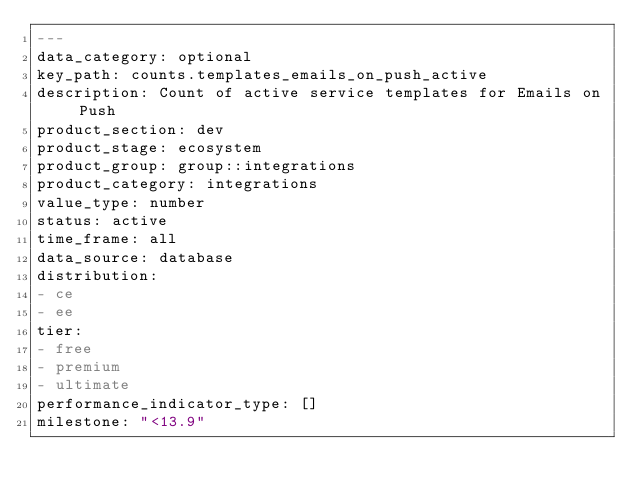<code> <loc_0><loc_0><loc_500><loc_500><_YAML_>---
data_category: optional
key_path: counts.templates_emails_on_push_active
description: Count of active service templates for Emails on Push
product_section: dev
product_stage: ecosystem
product_group: group::integrations
product_category: integrations
value_type: number
status: active
time_frame: all
data_source: database
distribution:
- ce
- ee
tier:
- free
- premium
- ultimate
performance_indicator_type: []
milestone: "<13.9"
</code> 